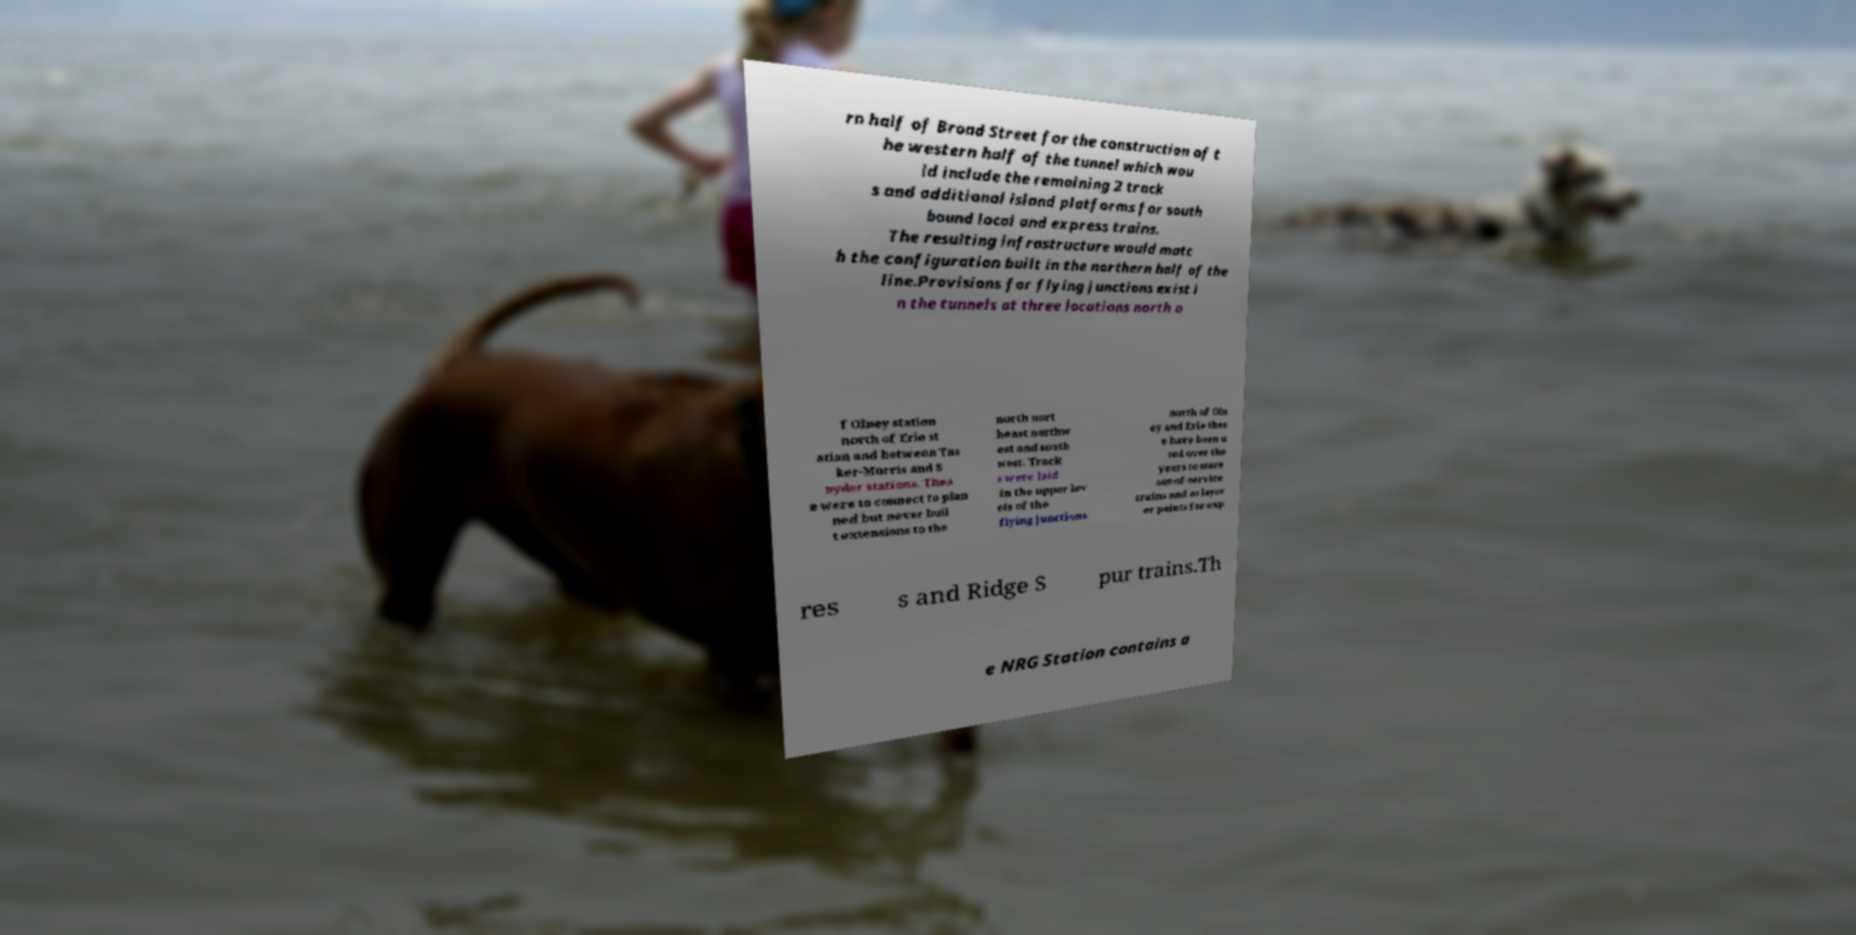Can you read and provide the text displayed in the image?This photo seems to have some interesting text. Can you extract and type it out for me? rn half of Broad Street for the construction of t he western half of the tunnel which wou ld include the remaining 2 track s and additional island platforms for south bound local and express trains. The resulting infrastructure would matc h the configuration built in the northern half of the line.Provisions for flying junctions exist i n the tunnels at three locations north o f Olney station north of Erie st ation and between Tas ker-Morris and S nyder stations. Thes e were to connect to plan ned but never buil t extensions to the north nort heast northw est and south west. Track s were laid in the upper lev els of the flying junctions north of Oln ey and Erie thes e have been u sed over the years to store out-of-service trains and as layov er points for exp res s and Ridge S pur trains.Th e NRG Station contains a 